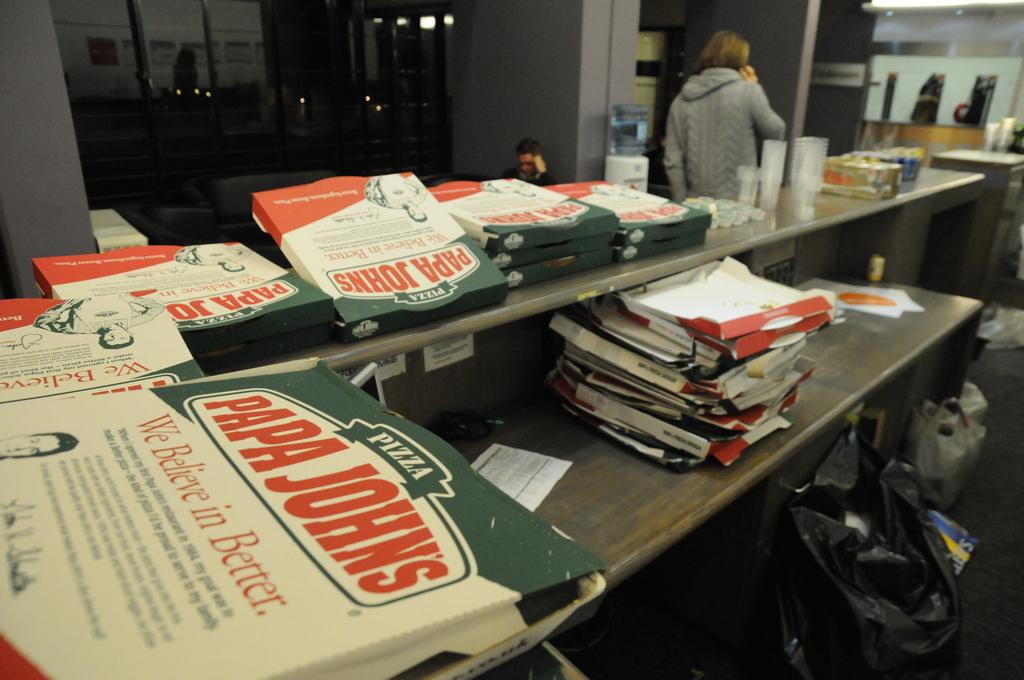What type of objects are on the table in the image? There are wooden objects on a table in the image. Can you describe the person standing beside the table? There is a person standing beside the table, but their appearance or actions are not specified in the facts. What else can be seen in the image besides the table and the person? There are other objects visible in the background of the image, but their nature is not specified in the facts. How many stamps are on the person's ticket in the image? There is no mention of stamps or tickets in the image, so this question cannot be answered definitively. 